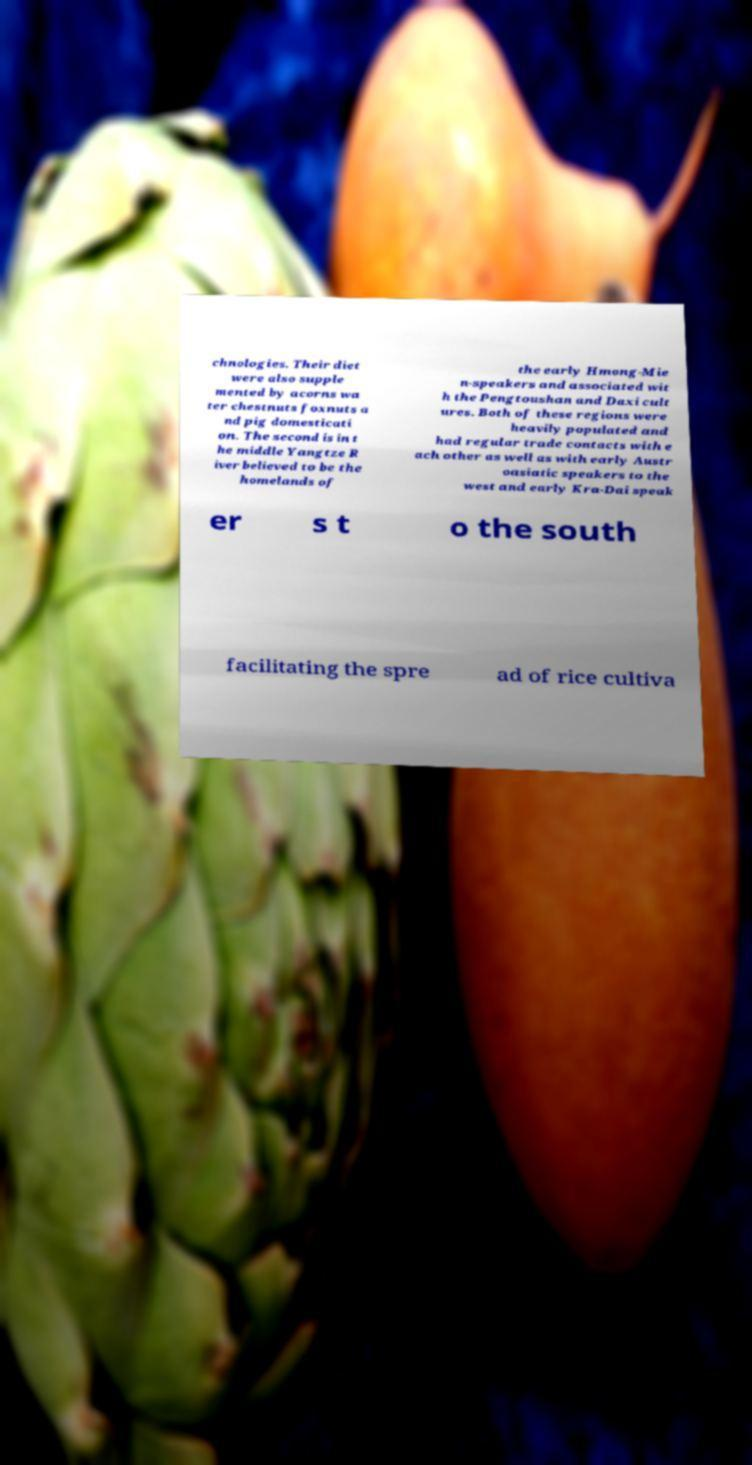Please read and relay the text visible in this image. What does it say? chnologies. Their diet were also supple mented by acorns wa ter chestnuts foxnuts a nd pig domesticati on. The second is in t he middle Yangtze R iver believed to be the homelands of the early Hmong-Mie n-speakers and associated wit h the Pengtoushan and Daxi cult ures. Both of these regions were heavily populated and had regular trade contacts with e ach other as well as with early Austr oasiatic speakers to the west and early Kra-Dai speak er s t o the south facilitating the spre ad of rice cultiva 